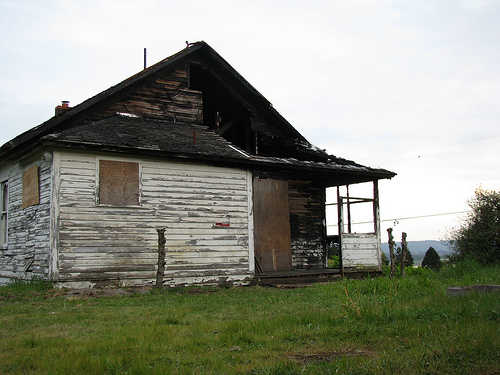<image>
Is the building in the sky? No. The building is not contained within the sky. These objects have a different spatial relationship. Where is the sky in relation to the house? Is it behind the house? Yes. From this viewpoint, the sky is positioned behind the house, with the house partially or fully occluding the sky. 